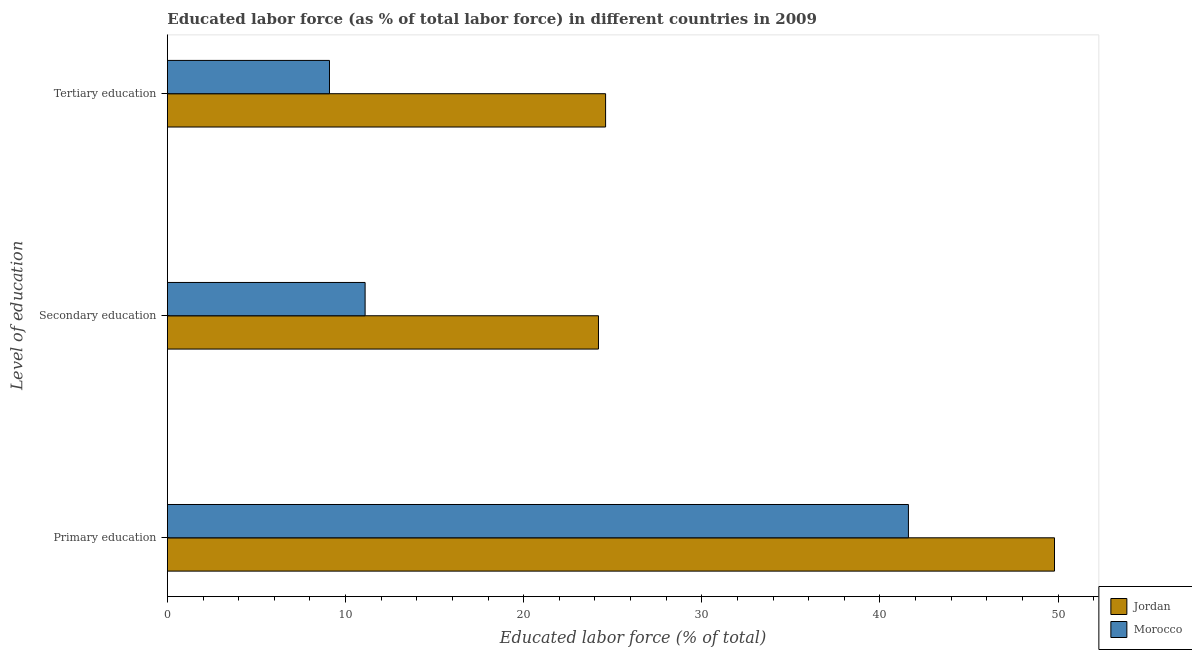How many bars are there on the 3rd tick from the bottom?
Offer a very short reply. 2. What is the label of the 1st group of bars from the top?
Ensure brevity in your answer.  Tertiary education. What is the percentage of labor force who received tertiary education in Morocco?
Provide a short and direct response. 9.1. Across all countries, what is the maximum percentage of labor force who received tertiary education?
Your answer should be compact. 24.6. Across all countries, what is the minimum percentage of labor force who received secondary education?
Your response must be concise. 11.1. In which country was the percentage of labor force who received tertiary education maximum?
Your answer should be very brief. Jordan. In which country was the percentage of labor force who received primary education minimum?
Make the answer very short. Morocco. What is the total percentage of labor force who received secondary education in the graph?
Give a very brief answer. 35.3. What is the difference between the percentage of labor force who received secondary education in Jordan and that in Morocco?
Offer a very short reply. 13.1. What is the difference between the percentage of labor force who received tertiary education in Jordan and the percentage of labor force who received secondary education in Morocco?
Give a very brief answer. 13.5. What is the average percentage of labor force who received secondary education per country?
Give a very brief answer. 17.65. What is the difference between the percentage of labor force who received tertiary education and percentage of labor force who received primary education in Morocco?
Provide a short and direct response. -32.5. In how many countries, is the percentage of labor force who received primary education greater than 28 %?
Provide a short and direct response. 2. What is the ratio of the percentage of labor force who received tertiary education in Morocco to that in Jordan?
Provide a succinct answer. 0.37. Is the percentage of labor force who received primary education in Morocco less than that in Jordan?
Ensure brevity in your answer.  Yes. What is the difference between the highest and the second highest percentage of labor force who received primary education?
Your answer should be compact. 8.2. What is the difference between the highest and the lowest percentage of labor force who received primary education?
Offer a very short reply. 8.2. In how many countries, is the percentage of labor force who received primary education greater than the average percentage of labor force who received primary education taken over all countries?
Provide a succinct answer. 1. Is the sum of the percentage of labor force who received tertiary education in Jordan and Morocco greater than the maximum percentage of labor force who received primary education across all countries?
Provide a succinct answer. No. What does the 1st bar from the top in Tertiary education represents?
Make the answer very short. Morocco. What does the 2nd bar from the bottom in Primary education represents?
Provide a short and direct response. Morocco. How many bars are there?
Ensure brevity in your answer.  6. Are all the bars in the graph horizontal?
Keep it short and to the point. Yes. What is the difference between two consecutive major ticks on the X-axis?
Provide a succinct answer. 10. Where does the legend appear in the graph?
Offer a terse response. Bottom right. What is the title of the graph?
Give a very brief answer. Educated labor force (as % of total labor force) in different countries in 2009. What is the label or title of the X-axis?
Provide a short and direct response. Educated labor force (% of total). What is the label or title of the Y-axis?
Offer a very short reply. Level of education. What is the Educated labor force (% of total) in Jordan in Primary education?
Keep it short and to the point. 49.8. What is the Educated labor force (% of total) of Morocco in Primary education?
Your answer should be very brief. 41.6. What is the Educated labor force (% of total) of Jordan in Secondary education?
Make the answer very short. 24.2. What is the Educated labor force (% of total) in Morocco in Secondary education?
Provide a short and direct response. 11.1. What is the Educated labor force (% of total) in Jordan in Tertiary education?
Make the answer very short. 24.6. What is the Educated labor force (% of total) of Morocco in Tertiary education?
Ensure brevity in your answer.  9.1. Across all Level of education, what is the maximum Educated labor force (% of total) of Jordan?
Your response must be concise. 49.8. Across all Level of education, what is the maximum Educated labor force (% of total) in Morocco?
Your response must be concise. 41.6. Across all Level of education, what is the minimum Educated labor force (% of total) in Jordan?
Your answer should be very brief. 24.2. Across all Level of education, what is the minimum Educated labor force (% of total) of Morocco?
Offer a very short reply. 9.1. What is the total Educated labor force (% of total) in Jordan in the graph?
Keep it short and to the point. 98.6. What is the total Educated labor force (% of total) in Morocco in the graph?
Your response must be concise. 61.8. What is the difference between the Educated labor force (% of total) of Jordan in Primary education and that in Secondary education?
Give a very brief answer. 25.6. What is the difference between the Educated labor force (% of total) in Morocco in Primary education and that in Secondary education?
Your response must be concise. 30.5. What is the difference between the Educated labor force (% of total) of Jordan in Primary education and that in Tertiary education?
Your answer should be compact. 25.2. What is the difference between the Educated labor force (% of total) in Morocco in Primary education and that in Tertiary education?
Make the answer very short. 32.5. What is the difference between the Educated labor force (% of total) of Jordan in Primary education and the Educated labor force (% of total) of Morocco in Secondary education?
Provide a short and direct response. 38.7. What is the difference between the Educated labor force (% of total) in Jordan in Primary education and the Educated labor force (% of total) in Morocco in Tertiary education?
Ensure brevity in your answer.  40.7. What is the average Educated labor force (% of total) in Jordan per Level of education?
Your answer should be very brief. 32.87. What is the average Educated labor force (% of total) of Morocco per Level of education?
Provide a succinct answer. 20.6. What is the difference between the Educated labor force (% of total) in Jordan and Educated labor force (% of total) in Morocco in Secondary education?
Offer a terse response. 13.1. What is the difference between the Educated labor force (% of total) in Jordan and Educated labor force (% of total) in Morocco in Tertiary education?
Offer a very short reply. 15.5. What is the ratio of the Educated labor force (% of total) in Jordan in Primary education to that in Secondary education?
Your answer should be compact. 2.06. What is the ratio of the Educated labor force (% of total) of Morocco in Primary education to that in Secondary education?
Keep it short and to the point. 3.75. What is the ratio of the Educated labor force (% of total) of Jordan in Primary education to that in Tertiary education?
Keep it short and to the point. 2.02. What is the ratio of the Educated labor force (% of total) of Morocco in Primary education to that in Tertiary education?
Give a very brief answer. 4.57. What is the ratio of the Educated labor force (% of total) in Jordan in Secondary education to that in Tertiary education?
Your response must be concise. 0.98. What is the ratio of the Educated labor force (% of total) in Morocco in Secondary education to that in Tertiary education?
Provide a short and direct response. 1.22. What is the difference between the highest and the second highest Educated labor force (% of total) in Jordan?
Provide a short and direct response. 25.2. What is the difference between the highest and the second highest Educated labor force (% of total) of Morocco?
Give a very brief answer. 30.5. What is the difference between the highest and the lowest Educated labor force (% of total) in Jordan?
Ensure brevity in your answer.  25.6. What is the difference between the highest and the lowest Educated labor force (% of total) in Morocco?
Your response must be concise. 32.5. 